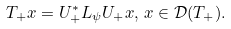Convert formula to latex. <formula><loc_0><loc_0><loc_500><loc_500>T _ { + } x = U _ { + } ^ { * } L _ { \psi } U _ { + } x , \, x \in \mathcal { D } ( T _ { + } ) .</formula> 